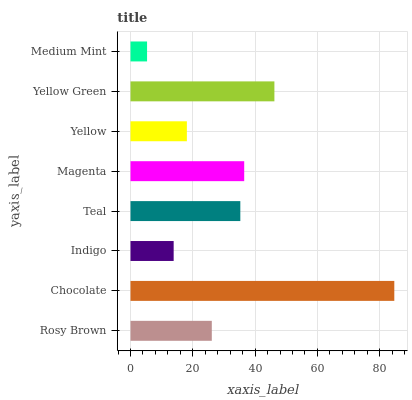Is Medium Mint the minimum?
Answer yes or no. Yes. Is Chocolate the maximum?
Answer yes or no. Yes. Is Indigo the minimum?
Answer yes or no. No. Is Indigo the maximum?
Answer yes or no. No. Is Chocolate greater than Indigo?
Answer yes or no. Yes. Is Indigo less than Chocolate?
Answer yes or no. Yes. Is Indigo greater than Chocolate?
Answer yes or no. No. Is Chocolate less than Indigo?
Answer yes or no. No. Is Teal the high median?
Answer yes or no. Yes. Is Rosy Brown the low median?
Answer yes or no. Yes. Is Chocolate the high median?
Answer yes or no. No. Is Yellow Green the low median?
Answer yes or no. No. 